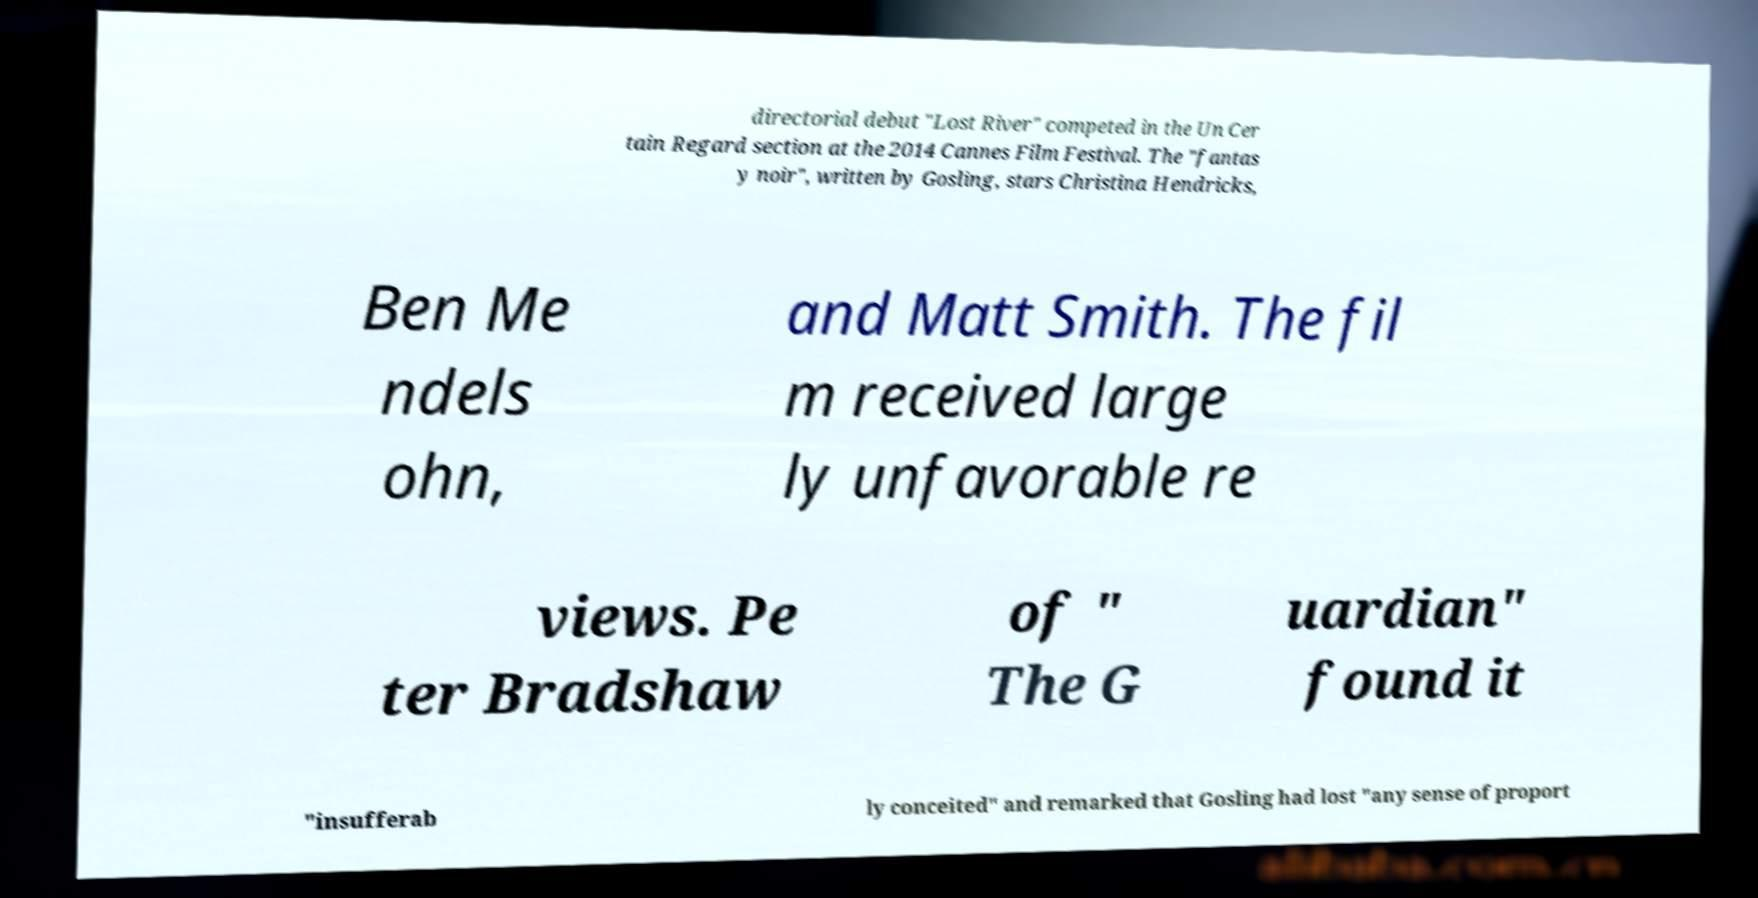Could you extract and type out the text from this image? directorial debut "Lost River" competed in the Un Cer tain Regard section at the 2014 Cannes Film Festival. The "fantas y noir", written by Gosling, stars Christina Hendricks, Ben Me ndels ohn, and Matt Smith. The fil m received large ly unfavorable re views. Pe ter Bradshaw of " The G uardian" found it "insufferab ly conceited" and remarked that Gosling had lost "any sense of proport 